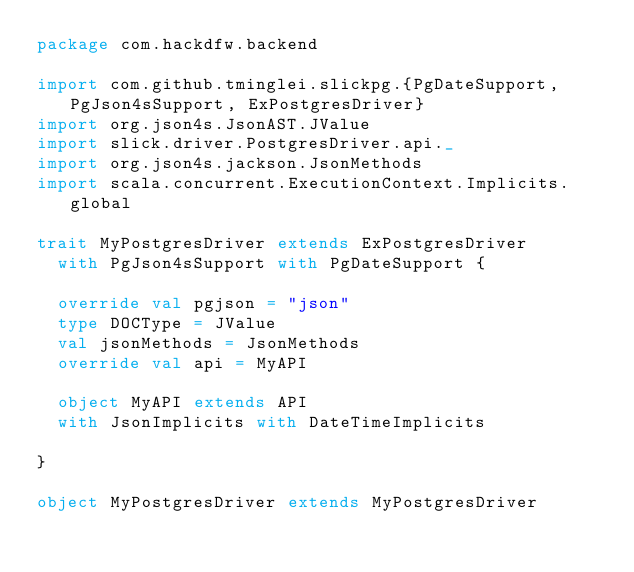<code> <loc_0><loc_0><loc_500><loc_500><_Scala_>package com.hackdfw.backend

import com.github.tminglei.slickpg.{PgDateSupport, PgJson4sSupport, ExPostgresDriver}
import org.json4s.JsonAST.JValue
import slick.driver.PostgresDriver.api._
import org.json4s.jackson.JsonMethods
import scala.concurrent.ExecutionContext.Implicits.global

trait MyPostgresDriver extends ExPostgresDriver
  with PgJson4sSupport with PgDateSupport {

  override val pgjson = "json"
  type DOCType = JValue
  val jsonMethods = JsonMethods
  override val api = MyAPI

  object MyAPI extends API
  with JsonImplicits with DateTimeImplicits

}

object MyPostgresDriver extends MyPostgresDriver
</code> 